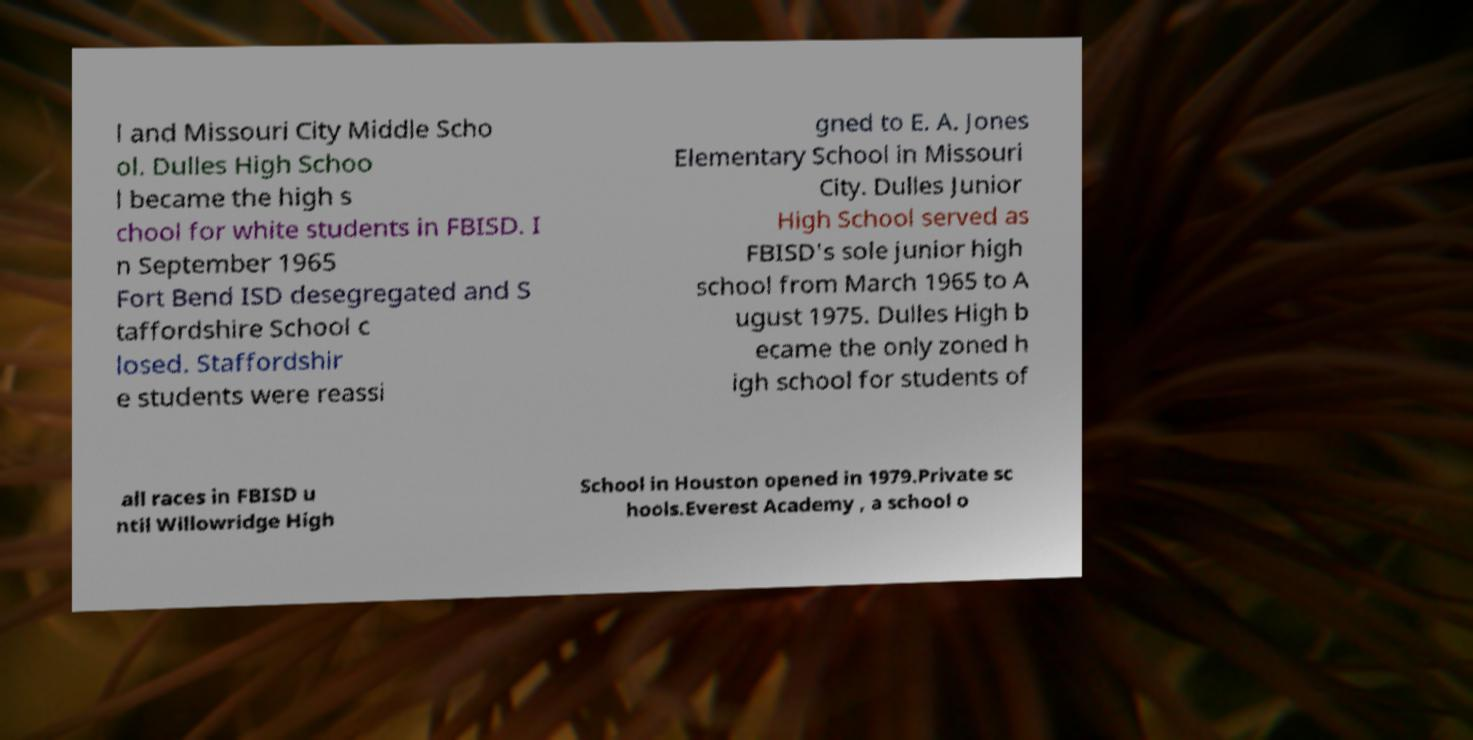Could you assist in decoding the text presented in this image and type it out clearly? l and Missouri City Middle Scho ol. Dulles High Schoo l became the high s chool for white students in FBISD. I n September 1965 Fort Bend ISD desegregated and S taffordshire School c losed. Staffordshir e students were reassi gned to E. A. Jones Elementary School in Missouri City. Dulles Junior High School served as FBISD's sole junior high school from March 1965 to A ugust 1975. Dulles High b ecame the only zoned h igh school for students of all races in FBISD u ntil Willowridge High School in Houston opened in 1979.Private sc hools.Everest Academy , a school o 